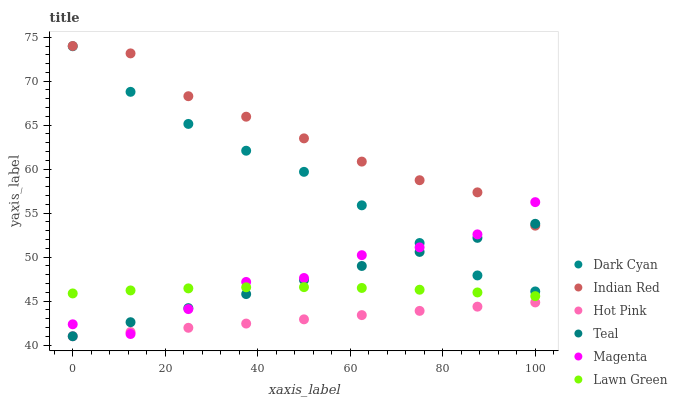Does Hot Pink have the minimum area under the curve?
Answer yes or no. Yes. Does Indian Red have the maximum area under the curve?
Answer yes or no. Yes. Does Indian Red have the minimum area under the curve?
Answer yes or no. No. Does Hot Pink have the maximum area under the curve?
Answer yes or no. No. Is Teal the smoothest?
Answer yes or no. Yes. Is Magenta the roughest?
Answer yes or no. Yes. Is Indian Red the smoothest?
Answer yes or no. No. Is Indian Red the roughest?
Answer yes or no. No. Does Hot Pink have the lowest value?
Answer yes or no. Yes. Does Indian Red have the lowest value?
Answer yes or no. No. Does Indian Red have the highest value?
Answer yes or no. Yes. Does Hot Pink have the highest value?
Answer yes or no. No. Is Lawn Green less than Dark Cyan?
Answer yes or no. Yes. Is Indian Red greater than Dark Cyan?
Answer yes or no. Yes. Does Hot Pink intersect Teal?
Answer yes or no. Yes. Is Hot Pink less than Teal?
Answer yes or no. No. Is Hot Pink greater than Teal?
Answer yes or no. No. Does Lawn Green intersect Dark Cyan?
Answer yes or no. No. 